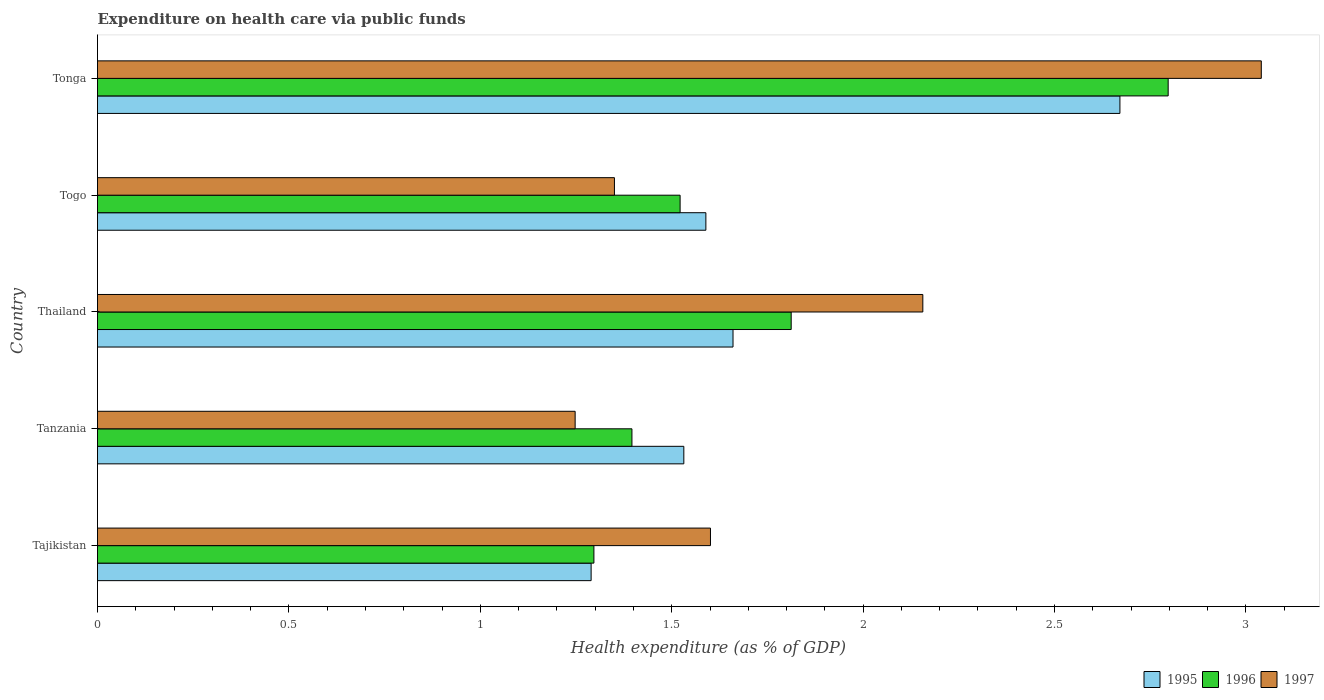How many different coloured bars are there?
Give a very brief answer. 3. Are the number of bars per tick equal to the number of legend labels?
Your response must be concise. Yes. How many bars are there on the 4th tick from the top?
Provide a short and direct response. 3. How many bars are there on the 5th tick from the bottom?
Provide a succinct answer. 3. What is the label of the 4th group of bars from the top?
Give a very brief answer. Tanzania. In how many cases, is the number of bars for a given country not equal to the number of legend labels?
Ensure brevity in your answer.  0. What is the expenditure made on health care in 1995 in Togo?
Your answer should be very brief. 1.59. Across all countries, what is the maximum expenditure made on health care in 1996?
Your answer should be very brief. 2.8. Across all countries, what is the minimum expenditure made on health care in 1997?
Make the answer very short. 1.25. In which country was the expenditure made on health care in 1997 maximum?
Keep it short and to the point. Tonga. In which country was the expenditure made on health care in 1995 minimum?
Keep it short and to the point. Tajikistan. What is the total expenditure made on health care in 1997 in the graph?
Keep it short and to the point. 9.4. What is the difference between the expenditure made on health care in 1997 in Tajikistan and that in Tonga?
Your answer should be very brief. -1.44. What is the difference between the expenditure made on health care in 1997 in Togo and the expenditure made on health care in 1995 in Tajikistan?
Make the answer very short. 0.06. What is the average expenditure made on health care in 1996 per country?
Your response must be concise. 1.76. What is the difference between the expenditure made on health care in 1996 and expenditure made on health care in 1995 in Thailand?
Offer a very short reply. 0.15. What is the ratio of the expenditure made on health care in 1995 in Tanzania to that in Thailand?
Provide a succinct answer. 0.92. Is the difference between the expenditure made on health care in 1996 in Tajikistan and Togo greater than the difference between the expenditure made on health care in 1995 in Tajikistan and Togo?
Keep it short and to the point. Yes. What is the difference between the highest and the second highest expenditure made on health care in 1996?
Offer a terse response. 0.98. What is the difference between the highest and the lowest expenditure made on health care in 1997?
Offer a very short reply. 1.79. Is the sum of the expenditure made on health care in 1995 in Thailand and Tonga greater than the maximum expenditure made on health care in 1997 across all countries?
Your answer should be very brief. Yes. What does the 3rd bar from the top in Thailand represents?
Give a very brief answer. 1995. How many bars are there?
Keep it short and to the point. 15. How many countries are there in the graph?
Your answer should be compact. 5. Does the graph contain any zero values?
Ensure brevity in your answer.  No. What is the title of the graph?
Your answer should be very brief. Expenditure on health care via public funds. What is the label or title of the X-axis?
Ensure brevity in your answer.  Health expenditure (as % of GDP). What is the label or title of the Y-axis?
Keep it short and to the point. Country. What is the Health expenditure (as % of GDP) of 1995 in Tajikistan?
Make the answer very short. 1.29. What is the Health expenditure (as % of GDP) of 1996 in Tajikistan?
Offer a terse response. 1.3. What is the Health expenditure (as % of GDP) of 1997 in Tajikistan?
Your response must be concise. 1.6. What is the Health expenditure (as % of GDP) in 1995 in Tanzania?
Make the answer very short. 1.53. What is the Health expenditure (as % of GDP) of 1996 in Tanzania?
Keep it short and to the point. 1.4. What is the Health expenditure (as % of GDP) in 1997 in Tanzania?
Provide a succinct answer. 1.25. What is the Health expenditure (as % of GDP) of 1995 in Thailand?
Offer a terse response. 1.66. What is the Health expenditure (as % of GDP) in 1996 in Thailand?
Offer a very short reply. 1.81. What is the Health expenditure (as % of GDP) of 1997 in Thailand?
Make the answer very short. 2.16. What is the Health expenditure (as % of GDP) in 1995 in Togo?
Your answer should be very brief. 1.59. What is the Health expenditure (as % of GDP) of 1996 in Togo?
Offer a very short reply. 1.52. What is the Health expenditure (as % of GDP) in 1997 in Togo?
Your answer should be compact. 1.35. What is the Health expenditure (as % of GDP) in 1995 in Tonga?
Your answer should be compact. 2.67. What is the Health expenditure (as % of GDP) of 1996 in Tonga?
Your response must be concise. 2.8. What is the Health expenditure (as % of GDP) of 1997 in Tonga?
Your response must be concise. 3.04. Across all countries, what is the maximum Health expenditure (as % of GDP) of 1995?
Ensure brevity in your answer.  2.67. Across all countries, what is the maximum Health expenditure (as % of GDP) in 1996?
Ensure brevity in your answer.  2.8. Across all countries, what is the maximum Health expenditure (as % of GDP) of 1997?
Your answer should be very brief. 3.04. Across all countries, what is the minimum Health expenditure (as % of GDP) of 1995?
Give a very brief answer. 1.29. Across all countries, what is the minimum Health expenditure (as % of GDP) of 1996?
Give a very brief answer. 1.3. Across all countries, what is the minimum Health expenditure (as % of GDP) in 1997?
Your answer should be very brief. 1.25. What is the total Health expenditure (as % of GDP) in 1995 in the graph?
Provide a short and direct response. 8.74. What is the total Health expenditure (as % of GDP) in 1996 in the graph?
Ensure brevity in your answer.  8.82. What is the total Health expenditure (as % of GDP) in 1997 in the graph?
Your response must be concise. 9.4. What is the difference between the Health expenditure (as % of GDP) in 1995 in Tajikistan and that in Tanzania?
Provide a succinct answer. -0.24. What is the difference between the Health expenditure (as % of GDP) of 1996 in Tajikistan and that in Tanzania?
Offer a very short reply. -0.1. What is the difference between the Health expenditure (as % of GDP) in 1997 in Tajikistan and that in Tanzania?
Give a very brief answer. 0.35. What is the difference between the Health expenditure (as % of GDP) of 1995 in Tajikistan and that in Thailand?
Give a very brief answer. -0.37. What is the difference between the Health expenditure (as % of GDP) in 1996 in Tajikistan and that in Thailand?
Offer a very short reply. -0.52. What is the difference between the Health expenditure (as % of GDP) of 1997 in Tajikistan and that in Thailand?
Make the answer very short. -0.55. What is the difference between the Health expenditure (as % of GDP) of 1995 in Tajikistan and that in Togo?
Provide a succinct answer. -0.3. What is the difference between the Health expenditure (as % of GDP) in 1996 in Tajikistan and that in Togo?
Ensure brevity in your answer.  -0.23. What is the difference between the Health expenditure (as % of GDP) in 1997 in Tajikistan and that in Togo?
Keep it short and to the point. 0.25. What is the difference between the Health expenditure (as % of GDP) in 1995 in Tajikistan and that in Tonga?
Your answer should be very brief. -1.38. What is the difference between the Health expenditure (as % of GDP) of 1996 in Tajikistan and that in Tonga?
Keep it short and to the point. -1.5. What is the difference between the Health expenditure (as % of GDP) of 1997 in Tajikistan and that in Tonga?
Your answer should be very brief. -1.44. What is the difference between the Health expenditure (as % of GDP) of 1995 in Tanzania and that in Thailand?
Ensure brevity in your answer.  -0.13. What is the difference between the Health expenditure (as % of GDP) in 1996 in Tanzania and that in Thailand?
Offer a terse response. -0.42. What is the difference between the Health expenditure (as % of GDP) in 1997 in Tanzania and that in Thailand?
Ensure brevity in your answer.  -0.91. What is the difference between the Health expenditure (as % of GDP) in 1995 in Tanzania and that in Togo?
Ensure brevity in your answer.  -0.06. What is the difference between the Health expenditure (as % of GDP) of 1996 in Tanzania and that in Togo?
Your answer should be very brief. -0.13. What is the difference between the Health expenditure (as % of GDP) of 1997 in Tanzania and that in Togo?
Give a very brief answer. -0.1. What is the difference between the Health expenditure (as % of GDP) in 1995 in Tanzania and that in Tonga?
Your answer should be compact. -1.14. What is the difference between the Health expenditure (as % of GDP) of 1996 in Tanzania and that in Tonga?
Your response must be concise. -1.4. What is the difference between the Health expenditure (as % of GDP) in 1997 in Tanzania and that in Tonga?
Keep it short and to the point. -1.79. What is the difference between the Health expenditure (as % of GDP) in 1995 in Thailand and that in Togo?
Your answer should be very brief. 0.07. What is the difference between the Health expenditure (as % of GDP) in 1996 in Thailand and that in Togo?
Offer a terse response. 0.29. What is the difference between the Health expenditure (as % of GDP) of 1997 in Thailand and that in Togo?
Keep it short and to the point. 0.81. What is the difference between the Health expenditure (as % of GDP) in 1995 in Thailand and that in Tonga?
Your response must be concise. -1.01. What is the difference between the Health expenditure (as % of GDP) in 1996 in Thailand and that in Tonga?
Keep it short and to the point. -0.98. What is the difference between the Health expenditure (as % of GDP) in 1997 in Thailand and that in Tonga?
Your answer should be compact. -0.88. What is the difference between the Health expenditure (as % of GDP) of 1995 in Togo and that in Tonga?
Ensure brevity in your answer.  -1.08. What is the difference between the Health expenditure (as % of GDP) of 1996 in Togo and that in Tonga?
Make the answer very short. -1.27. What is the difference between the Health expenditure (as % of GDP) in 1997 in Togo and that in Tonga?
Your answer should be very brief. -1.69. What is the difference between the Health expenditure (as % of GDP) of 1995 in Tajikistan and the Health expenditure (as % of GDP) of 1996 in Tanzania?
Ensure brevity in your answer.  -0.11. What is the difference between the Health expenditure (as % of GDP) of 1995 in Tajikistan and the Health expenditure (as % of GDP) of 1997 in Tanzania?
Make the answer very short. 0.04. What is the difference between the Health expenditure (as % of GDP) in 1996 in Tajikistan and the Health expenditure (as % of GDP) in 1997 in Tanzania?
Make the answer very short. 0.05. What is the difference between the Health expenditure (as % of GDP) in 1995 in Tajikistan and the Health expenditure (as % of GDP) in 1996 in Thailand?
Your answer should be compact. -0.52. What is the difference between the Health expenditure (as % of GDP) in 1995 in Tajikistan and the Health expenditure (as % of GDP) in 1997 in Thailand?
Give a very brief answer. -0.87. What is the difference between the Health expenditure (as % of GDP) of 1996 in Tajikistan and the Health expenditure (as % of GDP) of 1997 in Thailand?
Provide a short and direct response. -0.86. What is the difference between the Health expenditure (as % of GDP) of 1995 in Tajikistan and the Health expenditure (as % of GDP) of 1996 in Togo?
Offer a terse response. -0.23. What is the difference between the Health expenditure (as % of GDP) in 1995 in Tajikistan and the Health expenditure (as % of GDP) in 1997 in Togo?
Your response must be concise. -0.06. What is the difference between the Health expenditure (as % of GDP) in 1996 in Tajikistan and the Health expenditure (as % of GDP) in 1997 in Togo?
Ensure brevity in your answer.  -0.05. What is the difference between the Health expenditure (as % of GDP) of 1995 in Tajikistan and the Health expenditure (as % of GDP) of 1996 in Tonga?
Provide a succinct answer. -1.51. What is the difference between the Health expenditure (as % of GDP) in 1995 in Tajikistan and the Health expenditure (as % of GDP) in 1997 in Tonga?
Provide a short and direct response. -1.75. What is the difference between the Health expenditure (as % of GDP) of 1996 in Tajikistan and the Health expenditure (as % of GDP) of 1997 in Tonga?
Keep it short and to the point. -1.74. What is the difference between the Health expenditure (as % of GDP) of 1995 in Tanzania and the Health expenditure (as % of GDP) of 1996 in Thailand?
Provide a short and direct response. -0.28. What is the difference between the Health expenditure (as % of GDP) in 1995 in Tanzania and the Health expenditure (as % of GDP) in 1997 in Thailand?
Keep it short and to the point. -0.62. What is the difference between the Health expenditure (as % of GDP) in 1996 in Tanzania and the Health expenditure (as % of GDP) in 1997 in Thailand?
Give a very brief answer. -0.76. What is the difference between the Health expenditure (as % of GDP) of 1995 in Tanzania and the Health expenditure (as % of GDP) of 1996 in Togo?
Provide a short and direct response. 0.01. What is the difference between the Health expenditure (as % of GDP) in 1995 in Tanzania and the Health expenditure (as % of GDP) in 1997 in Togo?
Give a very brief answer. 0.18. What is the difference between the Health expenditure (as % of GDP) of 1996 in Tanzania and the Health expenditure (as % of GDP) of 1997 in Togo?
Provide a short and direct response. 0.05. What is the difference between the Health expenditure (as % of GDP) in 1995 in Tanzania and the Health expenditure (as % of GDP) in 1996 in Tonga?
Provide a short and direct response. -1.27. What is the difference between the Health expenditure (as % of GDP) in 1995 in Tanzania and the Health expenditure (as % of GDP) in 1997 in Tonga?
Your answer should be compact. -1.51. What is the difference between the Health expenditure (as % of GDP) of 1996 in Tanzania and the Health expenditure (as % of GDP) of 1997 in Tonga?
Give a very brief answer. -1.64. What is the difference between the Health expenditure (as % of GDP) in 1995 in Thailand and the Health expenditure (as % of GDP) in 1996 in Togo?
Offer a very short reply. 0.14. What is the difference between the Health expenditure (as % of GDP) in 1995 in Thailand and the Health expenditure (as % of GDP) in 1997 in Togo?
Give a very brief answer. 0.31. What is the difference between the Health expenditure (as % of GDP) in 1996 in Thailand and the Health expenditure (as % of GDP) in 1997 in Togo?
Provide a succinct answer. 0.46. What is the difference between the Health expenditure (as % of GDP) of 1995 in Thailand and the Health expenditure (as % of GDP) of 1996 in Tonga?
Provide a succinct answer. -1.14. What is the difference between the Health expenditure (as % of GDP) of 1995 in Thailand and the Health expenditure (as % of GDP) of 1997 in Tonga?
Give a very brief answer. -1.38. What is the difference between the Health expenditure (as % of GDP) of 1996 in Thailand and the Health expenditure (as % of GDP) of 1997 in Tonga?
Keep it short and to the point. -1.23. What is the difference between the Health expenditure (as % of GDP) of 1995 in Togo and the Health expenditure (as % of GDP) of 1996 in Tonga?
Your response must be concise. -1.21. What is the difference between the Health expenditure (as % of GDP) of 1995 in Togo and the Health expenditure (as % of GDP) of 1997 in Tonga?
Keep it short and to the point. -1.45. What is the difference between the Health expenditure (as % of GDP) of 1996 in Togo and the Health expenditure (as % of GDP) of 1997 in Tonga?
Your response must be concise. -1.52. What is the average Health expenditure (as % of GDP) of 1995 per country?
Your response must be concise. 1.75. What is the average Health expenditure (as % of GDP) of 1996 per country?
Provide a succinct answer. 1.76. What is the average Health expenditure (as % of GDP) in 1997 per country?
Offer a terse response. 1.88. What is the difference between the Health expenditure (as % of GDP) of 1995 and Health expenditure (as % of GDP) of 1996 in Tajikistan?
Your answer should be compact. -0.01. What is the difference between the Health expenditure (as % of GDP) in 1995 and Health expenditure (as % of GDP) in 1997 in Tajikistan?
Your answer should be very brief. -0.31. What is the difference between the Health expenditure (as % of GDP) of 1996 and Health expenditure (as % of GDP) of 1997 in Tajikistan?
Make the answer very short. -0.3. What is the difference between the Health expenditure (as % of GDP) of 1995 and Health expenditure (as % of GDP) of 1996 in Tanzania?
Your answer should be very brief. 0.14. What is the difference between the Health expenditure (as % of GDP) in 1995 and Health expenditure (as % of GDP) in 1997 in Tanzania?
Provide a short and direct response. 0.28. What is the difference between the Health expenditure (as % of GDP) in 1996 and Health expenditure (as % of GDP) in 1997 in Tanzania?
Your response must be concise. 0.15. What is the difference between the Health expenditure (as % of GDP) of 1995 and Health expenditure (as % of GDP) of 1996 in Thailand?
Keep it short and to the point. -0.15. What is the difference between the Health expenditure (as % of GDP) of 1995 and Health expenditure (as % of GDP) of 1997 in Thailand?
Provide a succinct answer. -0.5. What is the difference between the Health expenditure (as % of GDP) of 1996 and Health expenditure (as % of GDP) of 1997 in Thailand?
Offer a terse response. -0.34. What is the difference between the Health expenditure (as % of GDP) of 1995 and Health expenditure (as % of GDP) of 1996 in Togo?
Make the answer very short. 0.07. What is the difference between the Health expenditure (as % of GDP) in 1995 and Health expenditure (as % of GDP) in 1997 in Togo?
Provide a succinct answer. 0.24. What is the difference between the Health expenditure (as % of GDP) in 1996 and Health expenditure (as % of GDP) in 1997 in Togo?
Give a very brief answer. 0.17. What is the difference between the Health expenditure (as % of GDP) in 1995 and Health expenditure (as % of GDP) in 1996 in Tonga?
Your answer should be very brief. -0.13. What is the difference between the Health expenditure (as % of GDP) in 1995 and Health expenditure (as % of GDP) in 1997 in Tonga?
Make the answer very short. -0.37. What is the difference between the Health expenditure (as % of GDP) of 1996 and Health expenditure (as % of GDP) of 1997 in Tonga?
Your answer should be very brief. -0.24. What is the ratio of the Health expenditure (as % of GDP) of 1995 in Tajikistan to that in Tanzania?
Your response must be concise. 0.84. What is the ratio of the Health expenditure (as % of GDP) in 1996 in Tajikistan to that in Tanzania?
Give a very brief answer. 0.93. What is the ratio of the Health expenditure (as % of GDP) in 1997 in Tajikistan to that in Tanzania?
Provide a short and direct response. 1.28. What is the ratio of the Health expenditure (as % of GDP) in 1995 in Tajikistan to that in Thailand?
Your response must be concise. 0.78. What is the ratio of the Health expenditure (as % of GDP) in 1996 in Tajikistan to that in Thailand?
Provide a succinct answer. 0.72. What is the ratio of the Health expenditure (as % of GDP) of 1997 in Tajikistan to that in Thailand?
Your answer should be compact. 0.74. What is the ratio of the Health expenditure (as % of GDP) of 1995 in Tajikistan to that in Togo?
Your response must be concise. 0.81. What is the ratio of the Health expenditure (as % of GDP) in 1996 in Tajikistan to that in Togo?
Provide a short and direct response. 0.85. What is the ratio of the Health expenditure (as % of GDP) in 1997 in Tajikistan to that in Togo?
Provide a short and direct response. 1.19. What is the ratio of the Health expenditure (as % of GDP) of 1995 in Tajikistan to that in Tonga?
Ensure brevity in your answer.  0.48. What is the ratio of the Health expenditure (as % of GDP) of 1996 in Tajikistan to that in Tonga?
Provide a succinct answer. 0.46. What is the ratio of the Health expenditure (as % of GDP) in 1997 in Tajikistan to that in Tonga?
Provide a succinct answer. 0.53. What is the ratio of the Health expenditure (as % of GDP) of 1995 in Tanzania to that in Thailand?
Your answer should be compact. 0.92. What is the ratio of the Health expenditure (as % of GDP) of 1996 in Tanzania to that in Thailand?
Your response must be concise. 0.77. What is the ratio of the Health expenditure (as % of GDP) in 1997 in Tanzania to that in Thailand?
Give a very brief answer. 0.58. What is the ratio of the Health expenditure (as % of GDP) of 1995 in Tanzania to that in Togo?
Make the answer very short. 0.96. What is the ratio of the Health expenditure (as % of GDP) in 1996 in Tanzania to that in Togo?
Your response must be concise. 0.92. What is the ratio of the Health expenditure (as % of GDP) of 1997 in Tanzania to that in Togo?
Offer a terse response. 0.92. What is the ratio of the Health expenditure (as % of GDP) of 1995 in Tanzania to that in Tonga?
Provide a short and direct response. 0.57. What is the ratio of the Health expenditure (as % of GDP) of 1996 in Tanzania to that in Tonga?
Provide a short and direct response. 0.5. What is the ratio of the Health expenditure (as % of GDP) in 1997 in Tanzania to that in Tonga?
Your answer should be very brief. 0.41. What is the ratio of the Health expenditure (as % of GDP) in 1995 in Thailand to that in Togo?
Offer a very short reply. 1.04. What is the ratio of the Health expenditure (as % of GDP) of 1996 in Thailand to that in Togo?
Offer a terse response. 1.19. What is the ratio of the Health expenditure (as % of GDP) in 1997 in Thailand to that in Togo?
Your answer should be very brief. 1.6. What is the ratio of the Health expenditure (as % of GDP) in 1995 in Thailand to that in Tonga?
Make the answer very short. 0.62. What is the ratio of the Health expenditure (as % of GDP) of 1996 in Thailand to that in Tonga?
Offer a very short reply. 0.65. What is the ratio of the Health expenditure (as % of GDP) in 1997 in Thailand to that in Tonga?
Provide a short and direct response. 0.71. What is the ratio of the Health expenditure (as % of GDP) of 1995 in Togo to that in Tonga?
Ensure brevity in your answer.  0.59. What is the ratio of the Health expenditure (as % of GDP) in 1996 in Togo to that in Tonga?
Ensure brevity in your answer.  0.54. What is the ratio of the Health expenditure (as % of GDP) in 1997 in Togo to that in Tonga?
Give a very brief answer. 0.44. What is the difference between the highest and the second highest Health expenditure (as % of GDP) of 1995?
Your answer should be very brief. 1.01. What is the difference between the highest and the second highest Health expenditure (as % of GDP) in 1996?
Your response must be concise. 0.98. What is the difference between the highest and the second highest Health expenditure (as % of GDP) of 1997?
Keep it short and to the point. 0.88. What is the difference between the highest and the lowest Health expenditure (as % of GDP) of 1995?
Provide a short and direct response. 1.38. What is the difference between the highest and the lowest Health expenditure (as % of GDP) in 1996?
Provide a short and direct response. 1.5. What is the difference between the highest and the lowest Health expenditure (as % of GDP) of 1997?
Your response must be concise. 1.79. 